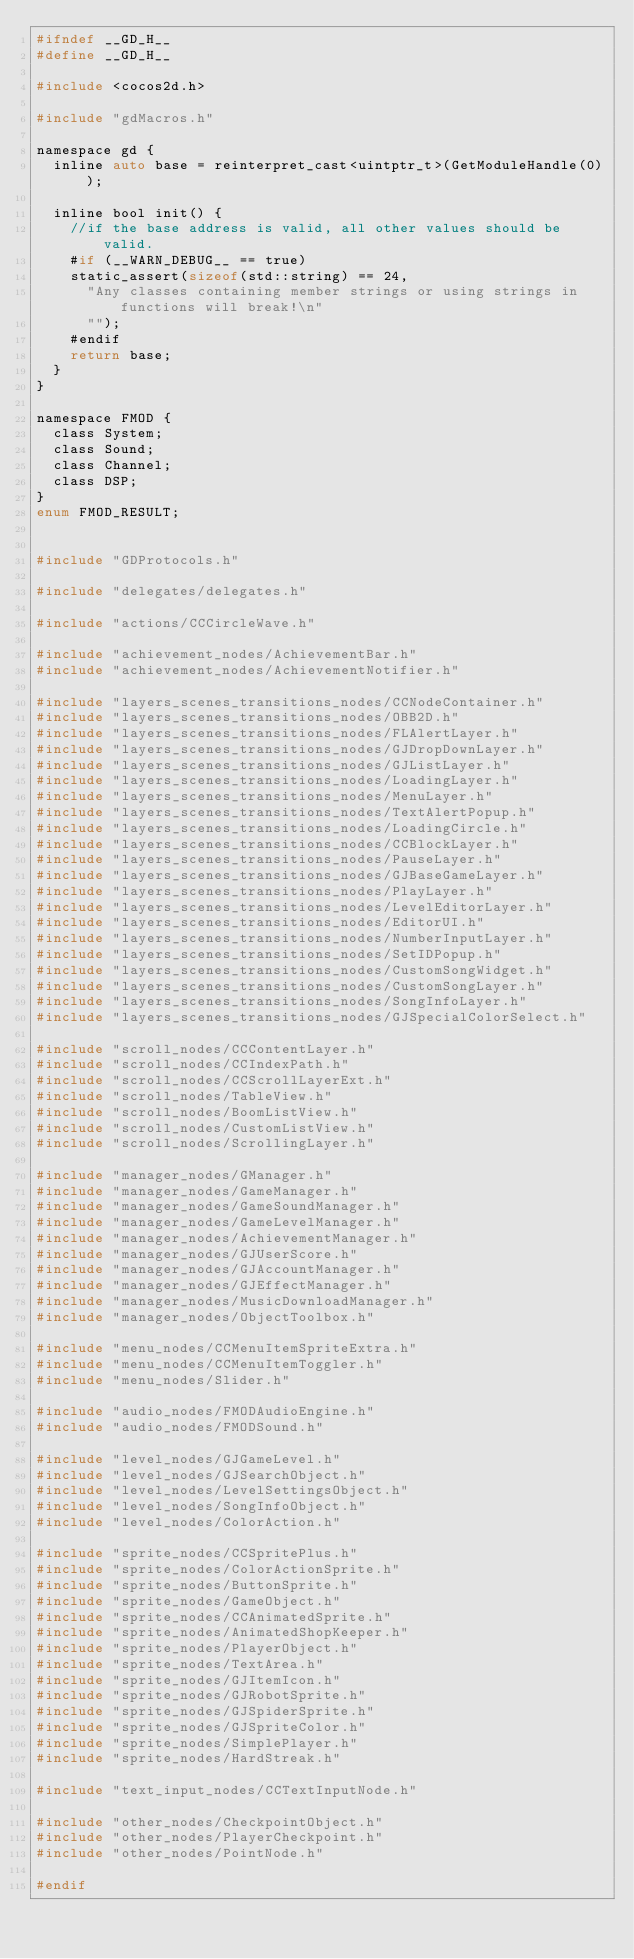Convert code to text. <code><loc_0><loc_0><loc_500><loc_500><_C_>#ifndef __GD_H__
#define __GD_H__

#include <cocos2d.h>

#include "gdMacros.h"

namespace gd {
	inline auto base = reinterpret_cast<uintptr_t>(GetModuleHandle(0));

	inline bool init() {
		//if the base address is valid, all other values should be valid.
		#if (__WARN_DEBUG__ == true)
		static_assert(sizeof(std::string) == 24,
			"Any classes containing member strings or using strings in functions will break!\n"
			"");
		#endif
		return base;
	}
}

namespace FMOD {
	class System;
	class Sound;
	class Channel;
	class DSP;
}
enum FMOD_RESULT;


#include "GDProtocols.h"

#include "delegates/delegates.h"

#include "actions/CCCircleWave.h"

#include "achievement_nodes/AchievementBar.h"
#include "achievement_nodes/AchievementNotifier.h"

#include "layers_scenes_transitions_nodes/CCNodeContainer.h"
#include "layers_scenes_transitions_nodes/OBB2D.h"
#include "layers_scenes_transitions_nodes/FLAlertLayer.h"
#include "layers_scenes_transitions_nodes/GJDropDownLayer.h"
#include "layers_scenes_transitions_nodes/GJListLayer.h"
#include "layers_scenes_transitions_nodes/LoadingLayer.h"
#include "layers_scenes_transitions_nodes/MenuLayer.h"
#include "layers_scenes_transitions_nodes/TextAlertPopup.h"
#include "layers_scenes_transitions_nodes/LoadingCircle.h"
#include "layers_scenes_transitions_nodes/CCBlockLayer.h"
#include "layers_scenes_transitions_nodes/PauseLayer.h"
#include "layers_scenes_transitions_nodes/GJBaseGameLayer.h"
#include "layers_scenes_transitions_nodes/PlayLayer.h"
#include "layers_scenes_transitions_nodes/LevelEditorLayer.h"
#include "layers_scenes_transitions_nodes/EditorUI.h"
#include "layers_scenes_transitions_nodes/NumberInputLayer.h"
#include "layers_scenes_transitions_nodes/SetIDPopup.h"
#include "layers_scenes_transitions_nodes/CustomSongWidget.h"
#include "layers_scenes_transitions_nodes/CustomSongLayer.h"
#include "layers_scenes_transitions_nodes/SongInfoLayer.h"
#include "layers_scenes_transitions_nodes/GJSpecialColorSelect.h"

#include "scroll_nodes/CCContentLayer.h"
#include "scroll_nodes/CCIndexPath.h"
#include "scroll_nodes/CCScrollLayerExt.h"
#include "scroll_nodes/TableView.h"
#include "scroll_nodes/BoomListView.h"
#include "scroll_nodes/CustomListView.h"
#include "scroll_nodes/ScrollingLayer.h"

#include "manager_nodes/GManager.h"
#include "manager_nodes/GameManager.h"
#include "manager_nodes/GameSoundManager.h"
#include "manager_nodes/GameLevelManager.h"
#include "manager_nodes/AchievementManager.h"
#include "manager_nodes/GJUserScore.h"
#include "manager_nodes/GJAccountManager.h"
#include "manager_nodes/GJEffectManager.h"
#include "manager_nodes/MusicDownloadManager.h"
#include "manager_nodes/ObjectToolbox.h"

#include "menu_nodes/CCMenuItemSpriteExtra.h"
#include "menu_nodes/CCMenuItemToggler.h"
#include "menu_nodes/Slider.h"

#include "audio_nodes/FMODAudioEngine.h"
#include "audio_nodes/FMODSound.h"

#include "level_nodes/GJGameLevel.h"
#include "level_nodes/GJSearchObject.h"
#include "level_nodes/LevelSettingsObject.h"
#include "level_nodes/SongInfoObject.h"
#include "level_nodes/ColorAction.h"

#include "sprite_nodes/CCSpritePlus.h"
#include "sprite_nodes/ColorActionSprite.h"
#include "sprite_nodes/ButtonSprite.h"
#include "sprite_nodes/GameObject.h"
#include "sprite_nodes/CCAnimatedSprite.h"
#include "sprite_nodes/AnimatedShopKeeper.h"
#include "sprite_nodes/PlayerObject.h"
#include "sprite_nodes/TextArea.h"
#include "sprite_nodes/GJItemIcon.h"
#include "sprite_nodes/GJRobotSprite.h"
#include "sprite_nodes/GJSpiderSprite.h"
#include "sprite_nodes/GJSpriteColor.h"
#include "sprite_nodes/SimplePlayer.h"
#include "sprite_nodes/HardStreak.h"

#include "text_input_nodes/CCTextInputNode.h"

#include "other_nodes/CheckpointObject.h"
#include "other_nodes/PlayerCheckpoint.h"
#include "other_nodes/PointNode.h"

#endif
</code> 